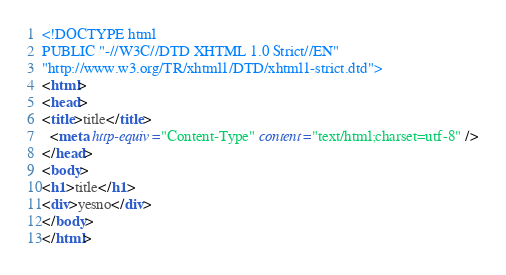Convert code to text. <code><loc_0><loc_0><loc_500><loc_500><_HTML_><!DOCTYPE html
PUBLIC "-//W3C//DTD XHTML 1.0 Strict//EN"
"http://www.w3.org/TR/xhtml1/DTD/xhtml1-strict.dtd">
<html>
<head>
<title>title</title>
  <meta http-equiv="Content-Type" content="text/html;charset=utf-8" />
</head>
<body>
<h1>title</h1>
<div>yesno</div>
</body>
</html></code> 